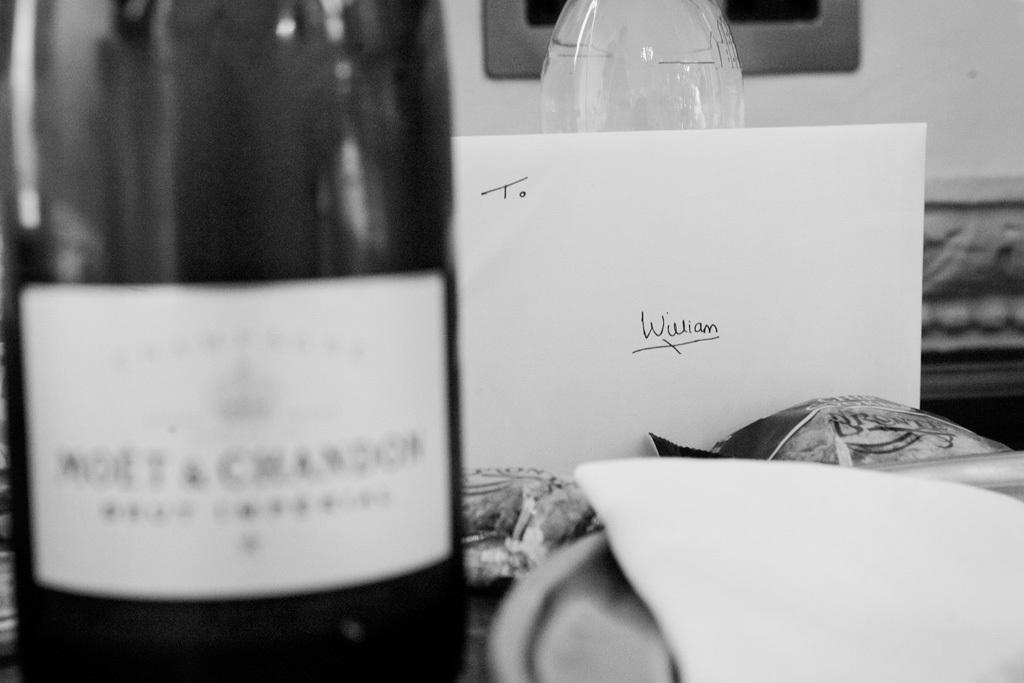Describe this image in one or two sentences. In this image I can see on the left side it looks like a wine bottle, on the right side there is a card with text on it. This image is in black and white color. 